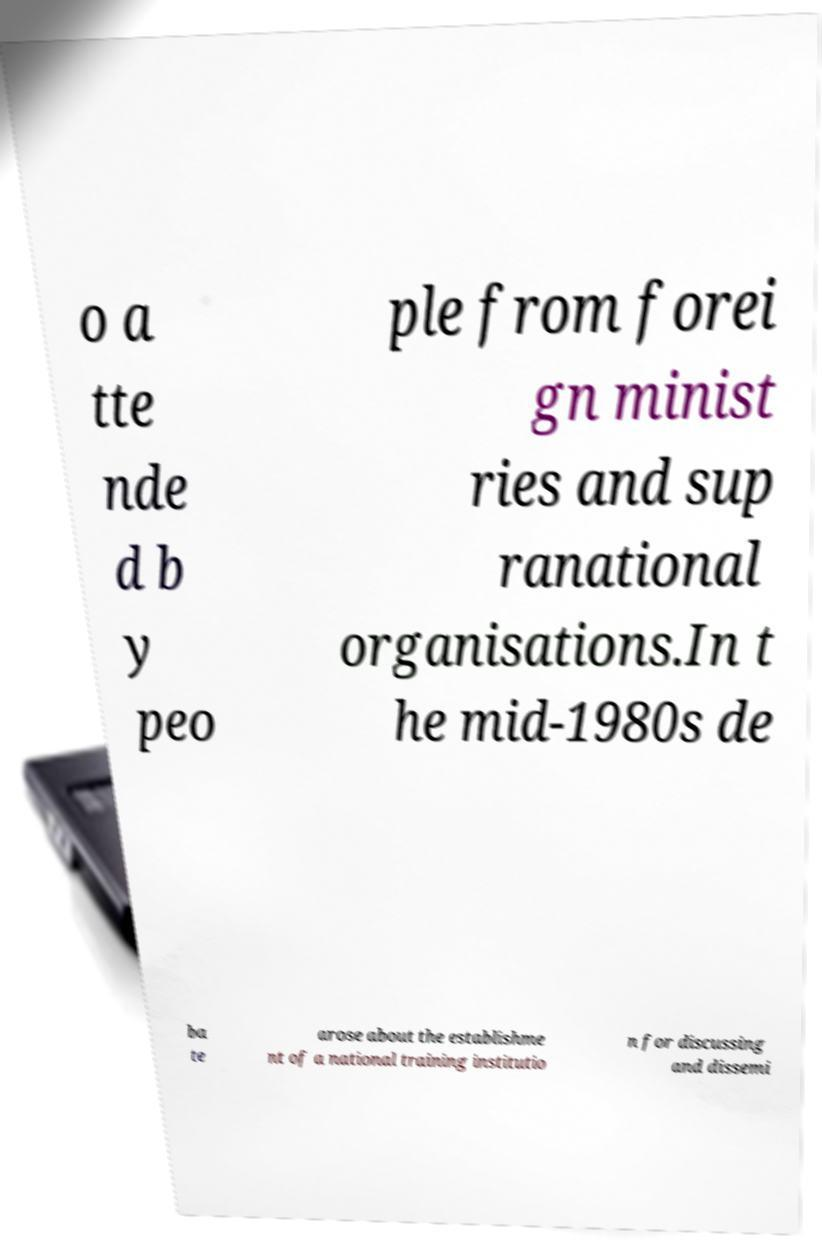There's text embedded in this image that I need extracted. Can you transcribe it verbatim? o a tte nde d b y peo ple from forei gn minist ries and sup ranational organisations.In t he mid-1980s de ba te arose about the establishme nt of a national training institutio n for discussing and dissemi 